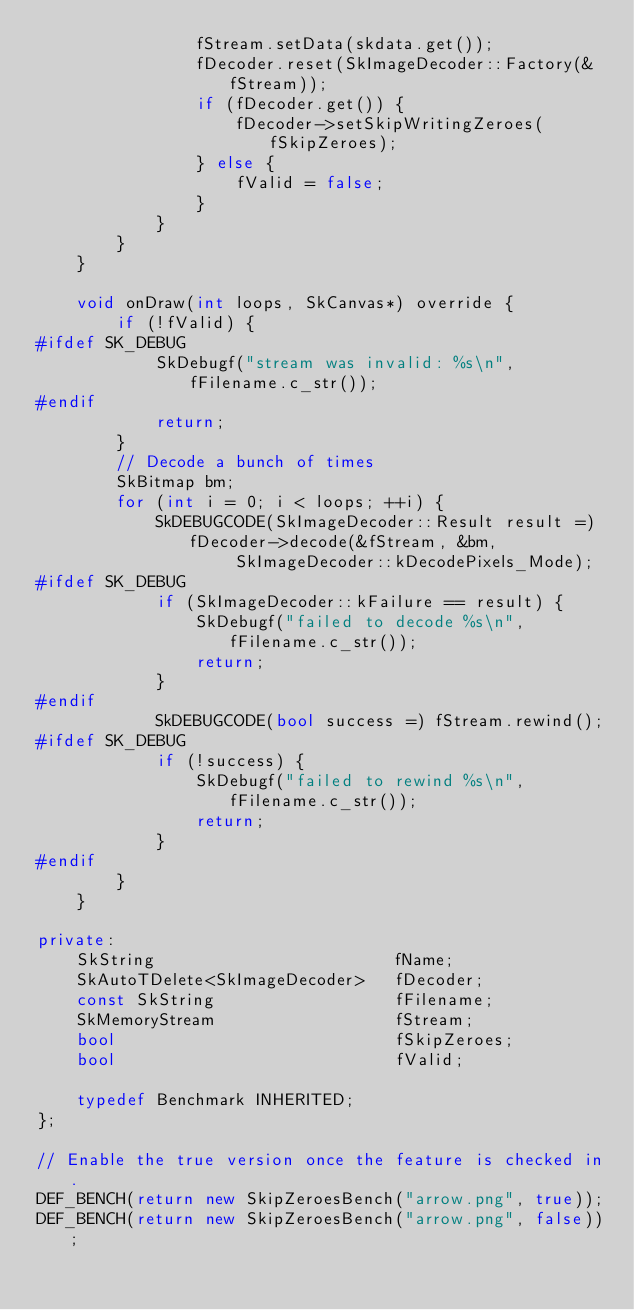Convert code to text. <code><loc_0><loc_0><loc_500><loc_500><_C++_>                fStream.setData(skdata.get());
                fDecoder.reset(SkImageDecoder::Factory(&fStream));
                if (fDecoder.get()) {
                    fDecoder->setSkipWritingZeroes(fSkipZeroes);
                } else {
                    fValid = false;
                }
            }
        }
    }

    void onDraw(int loops, SkCanvas*) override {
        if (!fValid) {
#ifdef SK_DEBUG
            SkDebugf("stream was invalid: %s\n", fFilename.c_str());
#endif
            return;
        }
        // Decode a bunch of times
        SkBitmap bm;
        for (int i = 0; i < loops; ++i) {
            SkDEBUGCODE(SkImageDecoder::Result result =) fDecoder->decode(&fStream, &bm,
                    SkImageDecoder::kDecodePixels_Mode);
#ifdef SK_DEBUG
            if (SkImageDecoder::kFailure == result) {
                SkDebugf("failed to decode %s\n", fFilename.c_str());
                return;
            }
#endif
            SkDEBUGCODE(bool success =) fStream.rewind();
#ifdef SK_DEBUG
            if (!success) {
                SkDebugf("failed to rewind %s\n", fFilename.c_str());
                return;
            }
#endif
        }
    }

private:
    SkString                        fName;
    SkAutoTDelete<SkImageDecoder>   fDecoder;
    const SkString                  fFilename;
    SkMemoryStream                  fStream;
    bool                            fSkipZeroes;
    bool                            fValid;

    typedef Benchmark INHERITED;
};

// Enable the true version once the feature is checked in.
DEF_BENCH(return new SkipZeroesBench("arrow.png", true));
DEF_BENCH(return new SkipZeroesBench("arrow.png", false));
</code> 